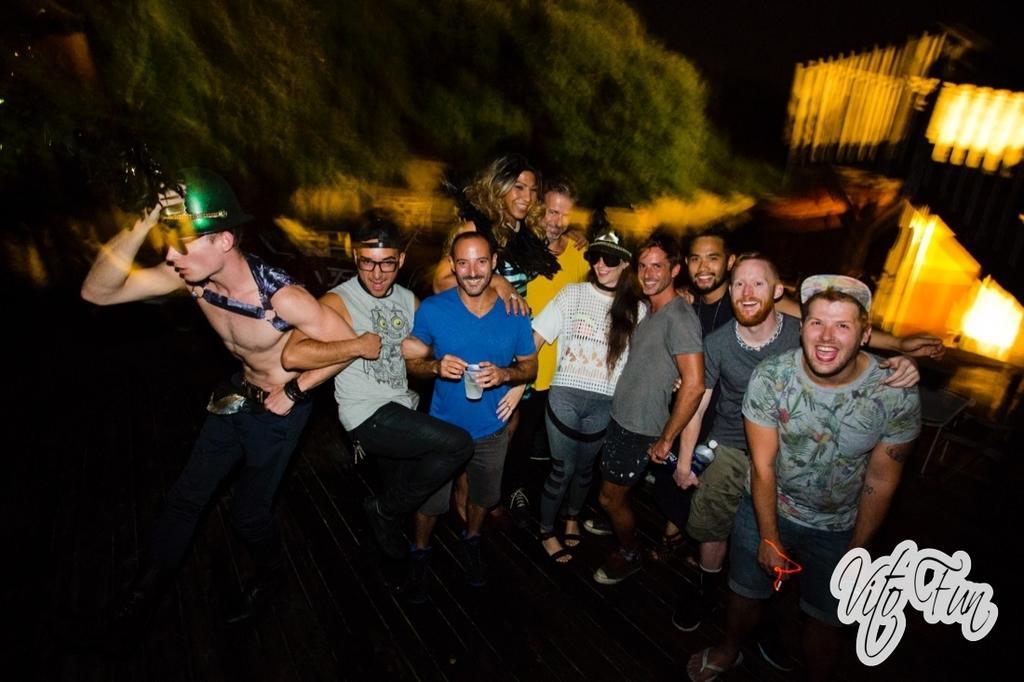Can you describe this image briefly? In this image we can see there are so many people standing in a group and smiling were few of them are dancing and one of them is holding glass with drink. 